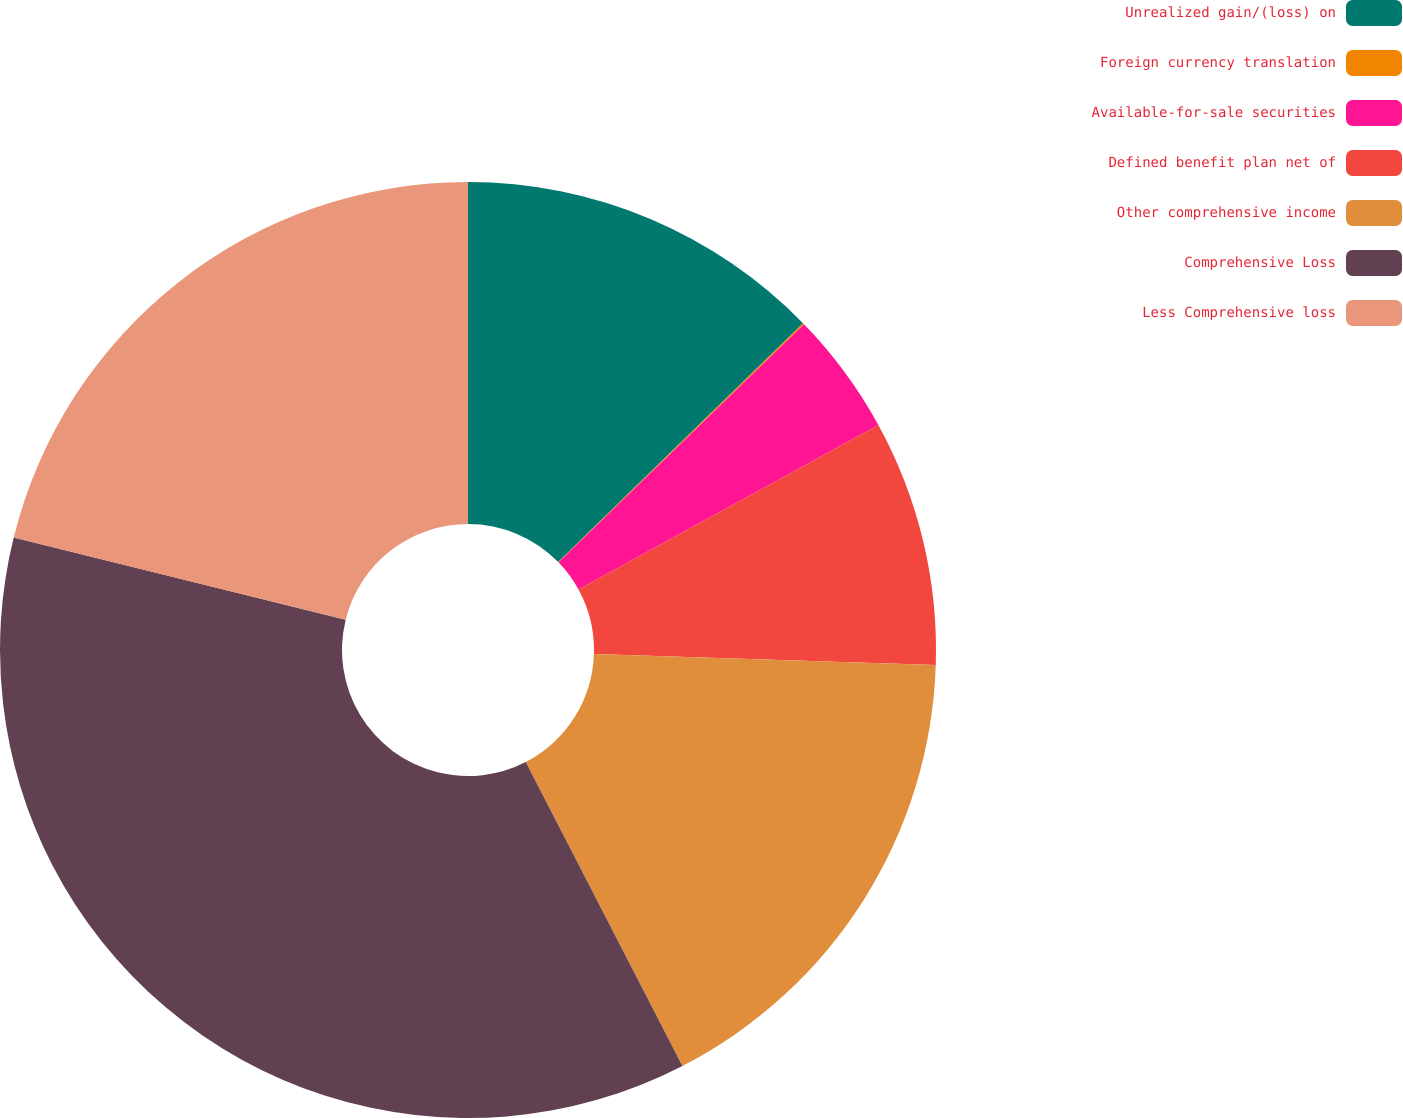Convert chart to OTSL. <chart><loc_0><loc_0><loc_500><loc_500><pie_chart><fcel>Unrealized gain/(loss) on<fcel>Foreign currency translation<fcel>Available-for-sale securities<fcel>Defined benefit plan net of<fcel>Other comprehensive income<fcel>Comprehensive Loss<fcel>Less Comprehensive loss<nl><fcel>12.7%<fcel>0.05%<fcel>4.27%<fcel>8.49%<fcel>16.92%<fcel>36.44%<fcel>21.14%<nl></chart> 